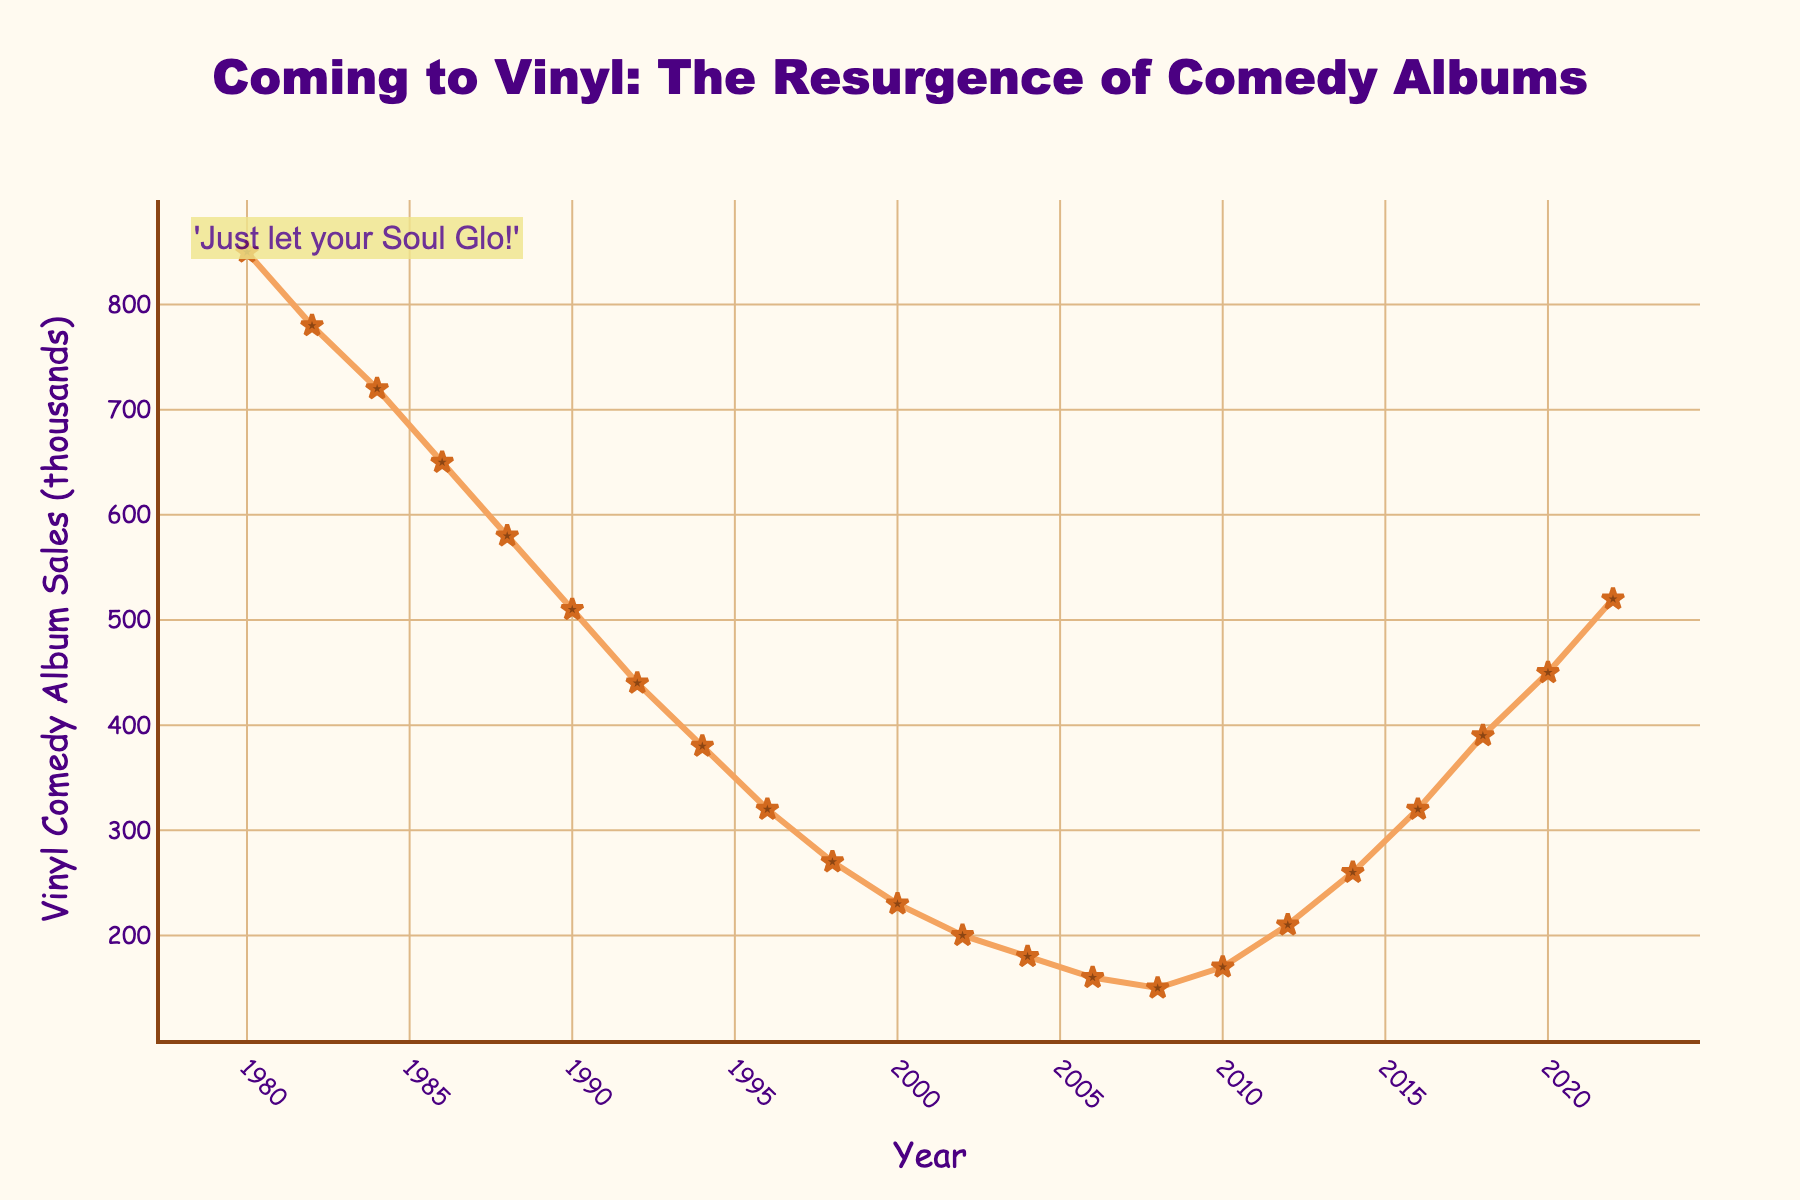What's the general trend of vinyl comedy album sales from 1980 to 2008? The general trend shows a decline in vinyl comedy album sales from 850,000 in 1980 to 150,000 in 2008, with a continuous drop every few years.
Answer: A decline When do vinyl comedy album sales begin to rise again? Vinyl comedy album sales start to rise again in 2010, increasing from 150,000 in 2008 to 170,000 in 2010 and continuing to increase in subsequent years.
Answer: 2010 How much did vinyl comedy album sales increase from 2010 to 2022? Sales increased from 170,000 in 2010 to 520,000 in 2022. The difference is 520,000 - 170,000 = 350,000.
Answer: 350,000 What is the highest sales value shown, and in which year does it occur? The highest sales value is 850,000, which occurs in the year 1980.
Answer: 850,000 in 1980 By how much did vinyl comedy album sales drop from 1980 to 1990? Sales dropped from 850,000 in 1980 to 510,000 in 1990. The difference is 850,000 - 510,000 = 340,000.
Answer: 340,000 From 2014 to 2020, what is the average annual increase in vinyl comedy album sales? Sales in 2014 were 260,000 and in 2020 were 450,000. The difference is 450,000 - 260,000 = 190,000. There are 6 years between 2014 and 2020, so the average annual increase is 190,000 / 6 = 31,666.67.
Answer: 31,666.67 Which year has the lowest vinyl comedy album sales, and what is the value? The year with the lowest sales is 2008, with a value of 150,000.
Answer: 2008 with 150,000 By how much did vinyl comedy album sales increase from 2016 to 2018? Sales increased from 320,000 in 2016 to 390,000 in 2018. The difference is 390,000 - 320,000 = 70,000.
Answer: 70,000 What visual attributes are used to highlight the trend line in the plot? The trend line is highlighted using a burnt orange color with star-shaped markers.
Answer: Burnt orange color with star-shaped markers During which decade did vinyl comedy album sales see the sharpest decline? From the data, the 1980s saw the sharpest decline in sales, dropping from 850,000 in 1980 to 580,000 in 1988, which is a decrease of 270,000.
Answer: 1980s 